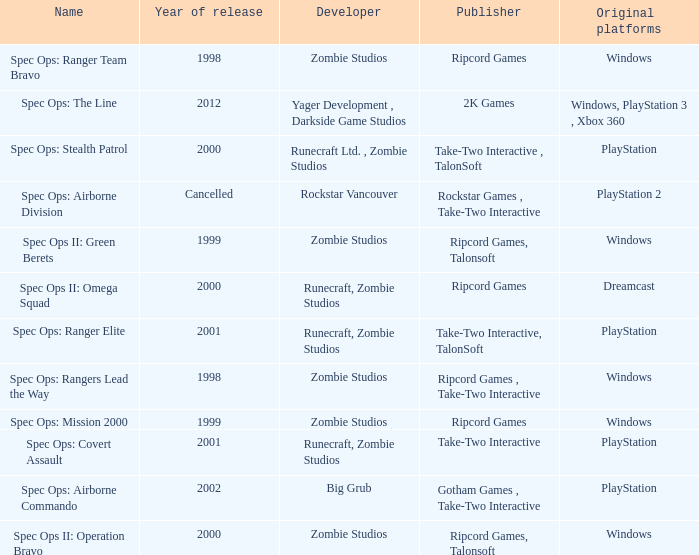Which developer has a year of cancelled releases? Rockstar Vancouver. 